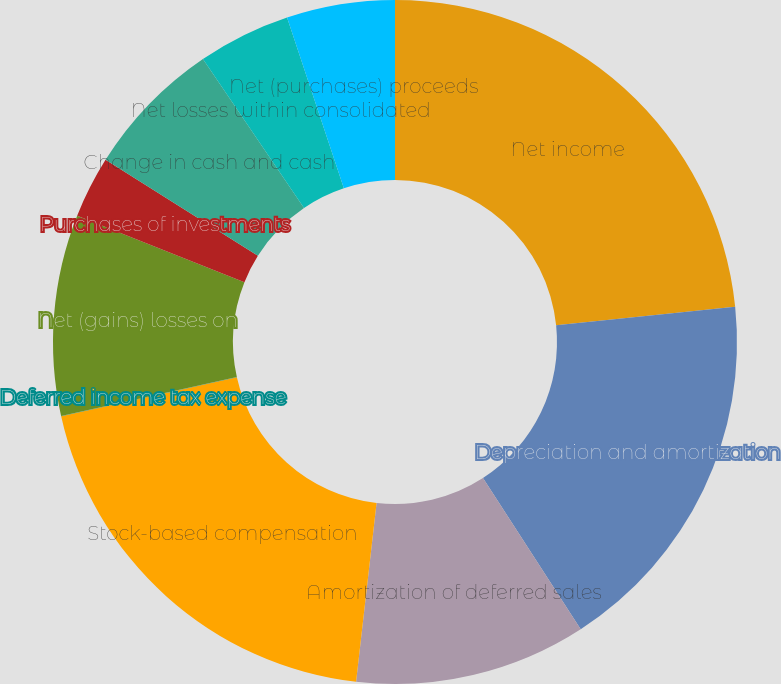Convert chart. <chart><loc_0><loc_0><loc_500><loc_500><pie_chart><fcel>Net income<fcel>Depreciation and amortization<fcel>Amortization of deferred sales<fcel>Stock-based compensation<fcel>Deferred income tax expense<fcel>Net (gains) losses on<fcel>Purchases of investments<fcel>Change in cash and cash<fcel>Net losses within consolidated<fcel>Net (purchases) proceeds<nl><fcel>23.35%<fcel>17.51%<fcel>10.95%<fcel>19.7%<fcel>0.01%<fcel>9.49%<fcel>2.92%<fcel>6.57%<fcel>4.38%<fcel>5.11%<nl></chart> 